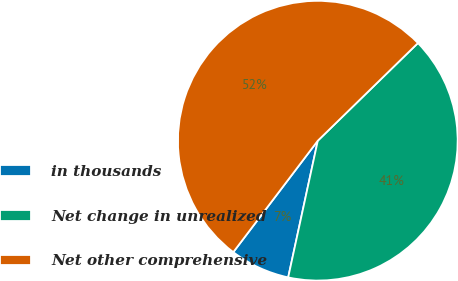<chart> <loc_0><loc_0><loc_500><loc_500><pie_chart><fcel>in thousands<fcel>Net change in unrealized<fcel>Net other comprehensive<nl><fcel>6.93%<fcel>40.69%<fcel>52.37%<nl></chart> 